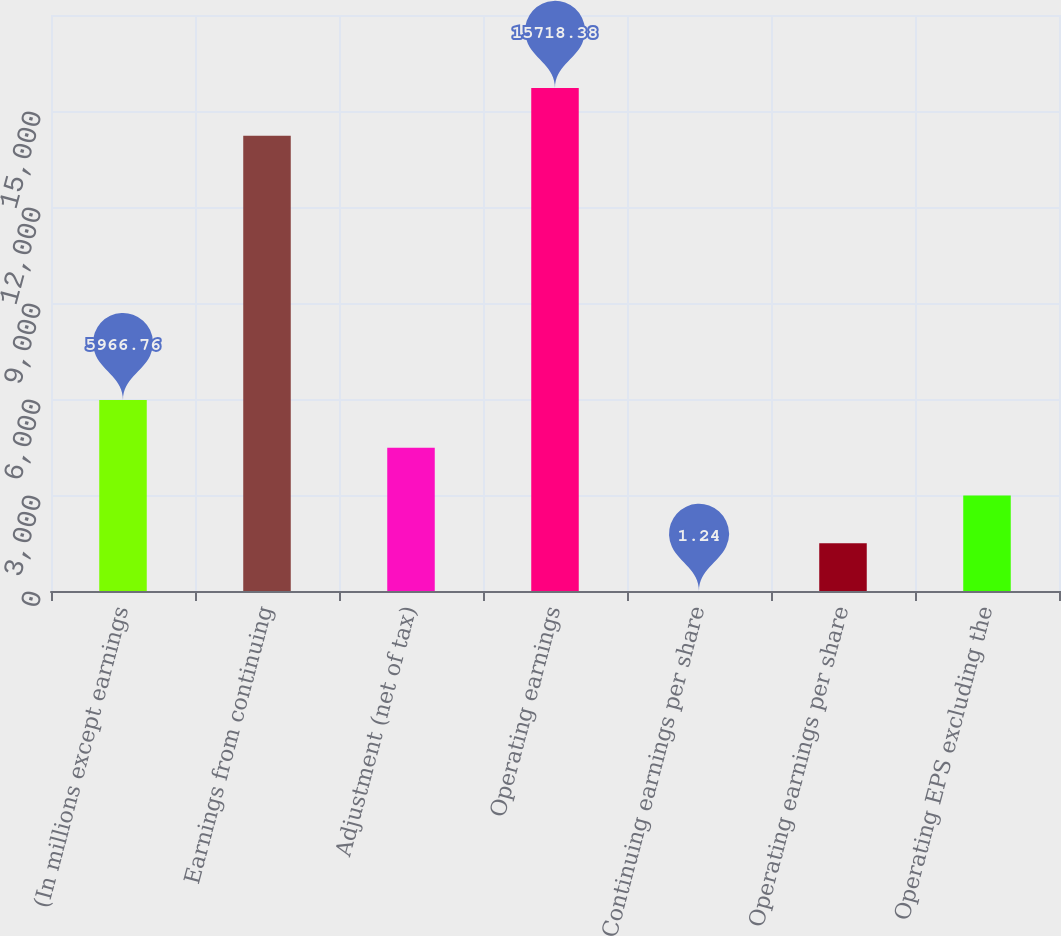<chart> <loc_0><loc_0><loc_500><loc_500><bar_chart><fcel>(In millions except earnings<fcel>Earnings from continuing<fcel>Adjustment (net of tax)<fcel>Operating earnings<fcel>Continuing earnings per share<fcel>Operating earnings per share<fcel>Operating EPS excluding the<nl><fcel>5966.76<fcel>14227<fcel>4475.38<fcel>15718.4<fcel>1.24<fcel>1492.62<fcel>2984<nl></chart> 